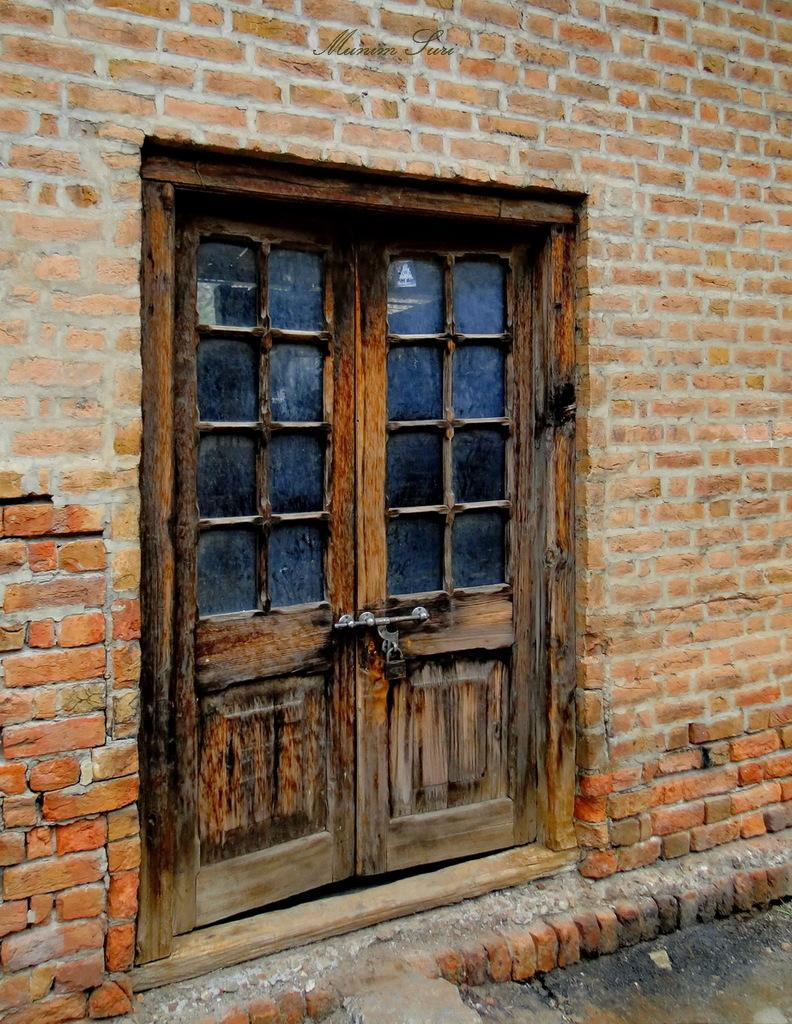What type of door is visible in the image? There is a wooden door in the image. What material is used for the wall in the image? There is a brick wall in the image. Where is the market located in the image? There is no market present in the image. What type of learning is taking place in the image? There is no learning activity depicted in the image. 